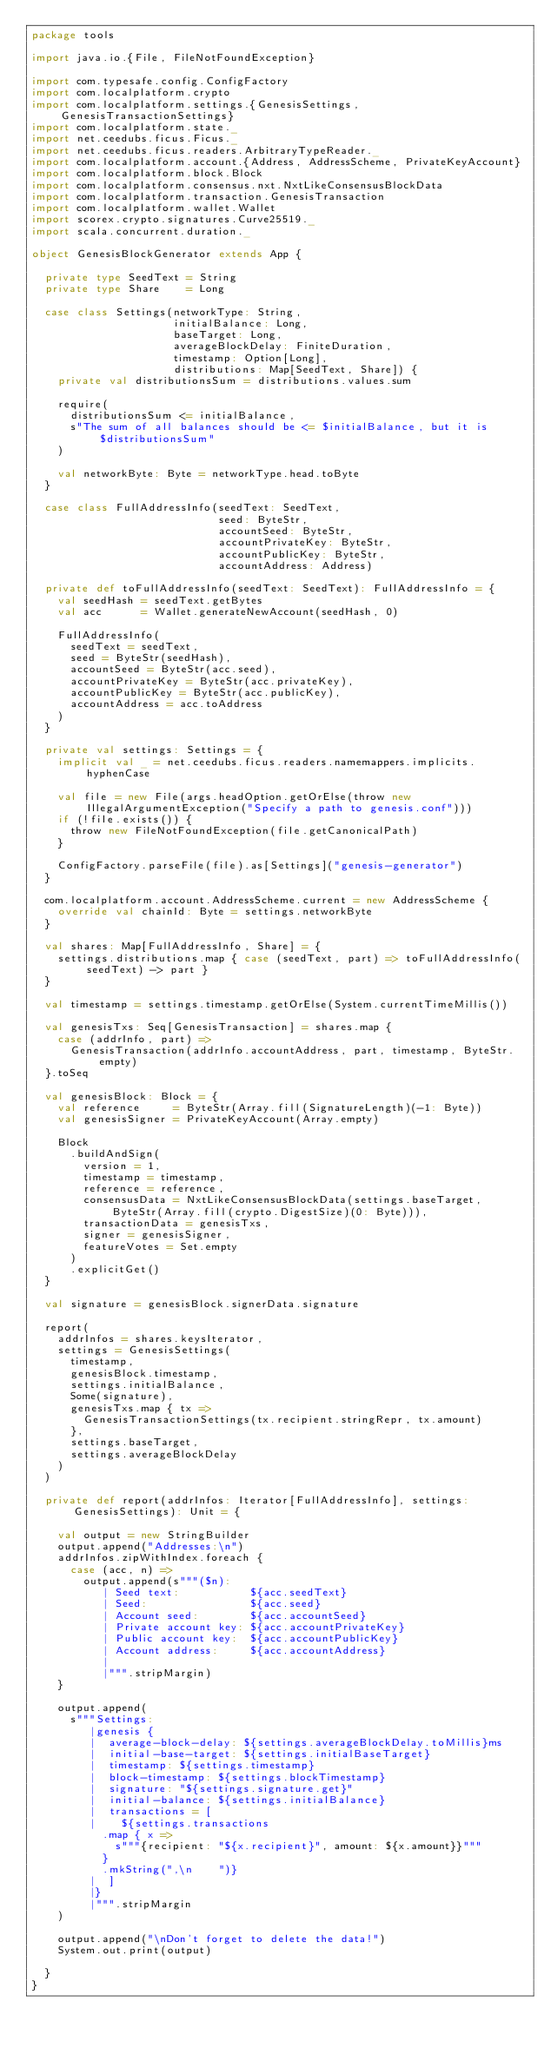<code> <loc_0><loc_0><loc_500><loc_500><_Scala_>package tools

import java.io.{File, FileNotFoundException}

import com.typesafe.config.ConfigFactory
import com.localplatform.crypto
import com.localplatform.settings.{GenesisSettings, GenesisTransactionSettings}
import com.localplatform.state._
import net.ceedubs.ficus.Ficus._
import net.ceedubs.ficus.readers.ArbitraryTypeReader._
import com.localplatform.account.{Address, AddressScheme, PrivateKeyAccount}
import com.localplatform.block.Block
import com.localplatform.consensus.nxt.NxtLikeConsensusBlockData
import com.localplatform.transaction.GenesisTransaction
import com.localplatform.wallet.Wallet
import scorex.crypto.signatures.Curve25519._
import scala.concurrent.duration._

object GenesisBlockGenerator extends App {

  private type SeedText = String
  private type Share    = Long

  case class Settings(networkType: String,
                      initialBalance: Long,
                      baseTarget: Long,
                      averageBlockDelay: FiniteDuration,
                      timestamp: Option[Long],
                      distributions: Map[SeedText, Share]) {
    private val distributionsSum = distributions.values.sum

    require(
      distributionsSum <= initialBalance,
      s"The sum of all balances should be <= $initialBalance, but it is $distributionsSum"
    )

    val networkByte: Byte = networkType.head.toByte
  }

  case class FullAddressInfo(seedText: SeedText,
                             seed: ByteStr,
                             accountSeed: ByteStr,
                             accountPrivateKey: ByteStr,
                             accountPublicKey: ByteStr,
                             accountAddress: Address)

  private def toFullAddressInfo(seedText: SeedText): FullAddressInfo = {
    val seedHash = seedText.getBytes
    val acc      = Wallet.generateNewAccount(seedHash, 0)

    FullAddressInfo(
      seedText = seedText,
      seed = ByteStr(seedHash),
      accountSeed = ByteStr(acc.seed),
      accountPrivateKey = ByteStr(acc.privateKey),
      accountPublicKey = ByteStr(acc.publicKey),
      accountAddress = acc.toAddress
    )
  }

  private val settings: Settings = {
    implicit val _ = net.ceedubs.ficus.readers.namemappers.implicits.hyphenCase

    val file = new File(args.headOption.getOrElse(throw new IllegalArgumentException("Specify a path to genesis.conf")))
    if (!file.exists()) {
      throw new FileNotFoundException(file.getCanonicalPath)
    }

    ConfigFactory.parseFile(file).as[Settings]("genesis-generator")
  }

  com.localplatform.account.AddressScheme.current = new AddressScheme {
    override val chainId: Byte = settings.networkByte
  }

  val shares: Map[FullAddressInfo, Share] = {
    settings.distributions.map { case (seedText, part) => toFullAddressInfo(seedText) -> part }
  }

  val timestamp = settings.timestamp.getOrElse(System.currentTimeMillis())

  val genesisTxs: Seq[GenesisTransaction] = shares.map {
    case (addrInfo, part) =>
      GenesisTransaction(addrInfo.accountAddress, part, timestamp, ByteStr.empty)
  }.toSeq

  val genesisBlock: Block = {
    val reference     = ByteStr(Array.fill(SignatureLength)(-1: Byte))
    val genesisSigner = PrivateKeyAccount(Array.empty)

    Block
      .buildAndSign(
        version = 1,
        timestamp = timestamp,
        reference = reference,
        consensusData = NxtLikeConsensusBlockData(settings.baseTarget, ByteStr(Array.fill(crypto.DigestSize)(0: Byte))),
        transactionData = genesisTxs,
        signer = genesisSigner,
        featureVotes = Set.empty
      )
      .explicitGet()
  }

  val signature = genesisBlock.signerData.signature

  report(
    addrInfos = shares.keysIterator,
    settings = GenesisSettings(
      timestamp,
      genesisBlock.timestamp,
      settings.initialBalance,
      Some(signature),
      genesisTxs.map { tx =>
        GenesisTransactionSettings(tx.recipient.stringRepr, tx.amount)
      },
      settings.baseTarget,
      settings.averageBlockDelay
    )
  )

  private def report(addrInfos: Iterator[FullAddressInfo], settings: GenesisSettings): Unit = {

    val output = new StringBuilder
    output.append("Addresses:\n")
    addrInfos.zipWithIndex.foreach {
      case (acc, n) =>
        output.append(s"""($n):
           | Seed text:           ${acc.seedText}
           | Seed:                ${acc.seed}
           | Account seed:        ${acc.accountSeed}
           | Private account key: ${acc.accountPrivateKey}
           | Public account key:  ${acc.accountPublicKey}
           | Account address:     ${acc.accountAddress}
           |
           |""".stripMargin)
    }

    output.append(
      s"""Settings:
         |genesis {
         |  average-block-delay: ${settings.averageBlockDelay.toMillis}ms
         |  initial-base-target: ${settings.initialBaseTarget}
         |  timestamp: ${settings.timestamp}
         |  block-timestamp: ${settings.blockTimestamp}
         |  signature: "${settings.signature.get}"
         |  initial-balance: ${settings.initialBalance}
         |  transactions = [
         |    ${settings.transactions
           .map { x =>
             s"""{recipient: "${x.recipient}", amount: ${x.amount}}"""
           }
           .mkString(",\n    ")}
         |  ]
         |}
         |""".stripMargin
    )

    output.append("\nDon't forget to delete the data!")
    System.out.print(output)

  }
}
</code> 